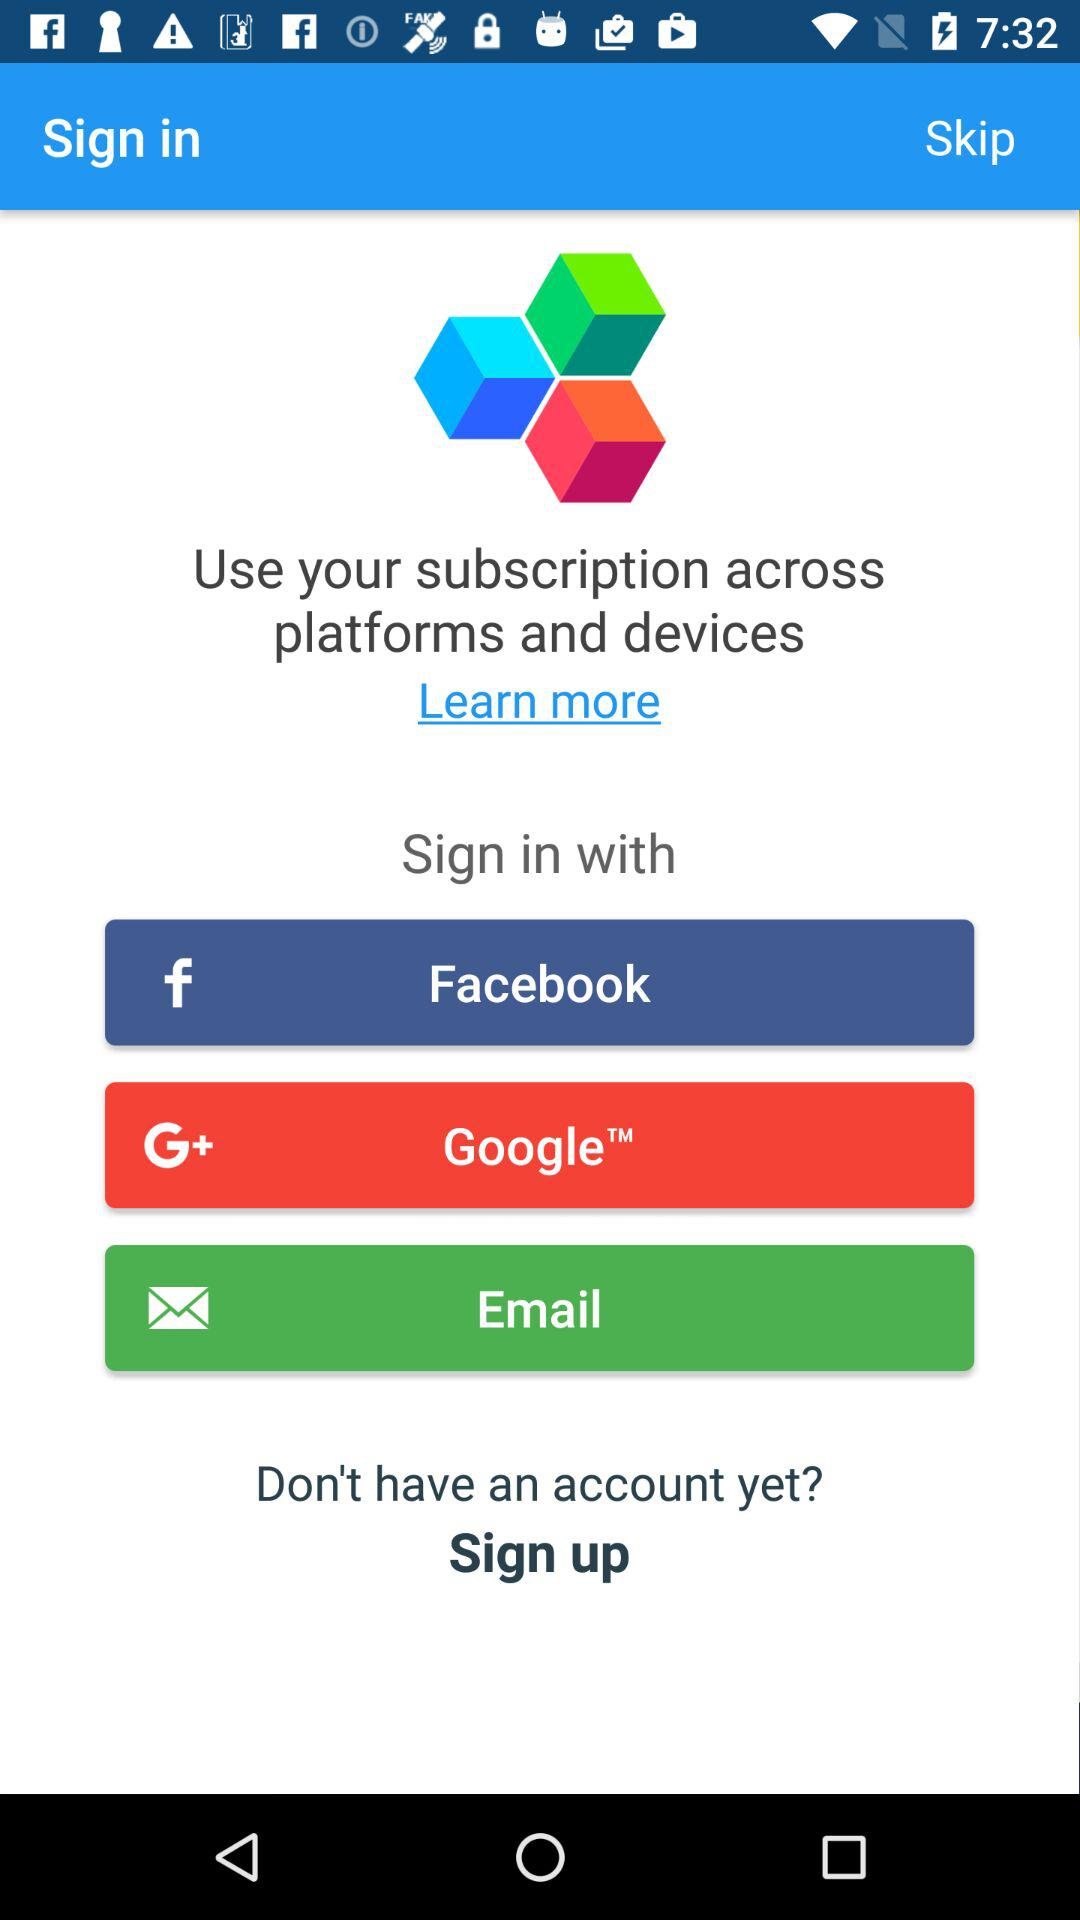What are the different options available for logging in? The different options are "Facebook", "Google" and "Email". 